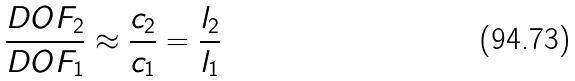<formula> <loc_0><loc_0><loc_500><loc_500>\frac { D O F _ { 2 } } { D O F _ { 1 } } \approx \frac { c _ { 2 } } { c _ { 1 } } = \frac { l _ { 2 } } { l _ { 1 } }</formula> 